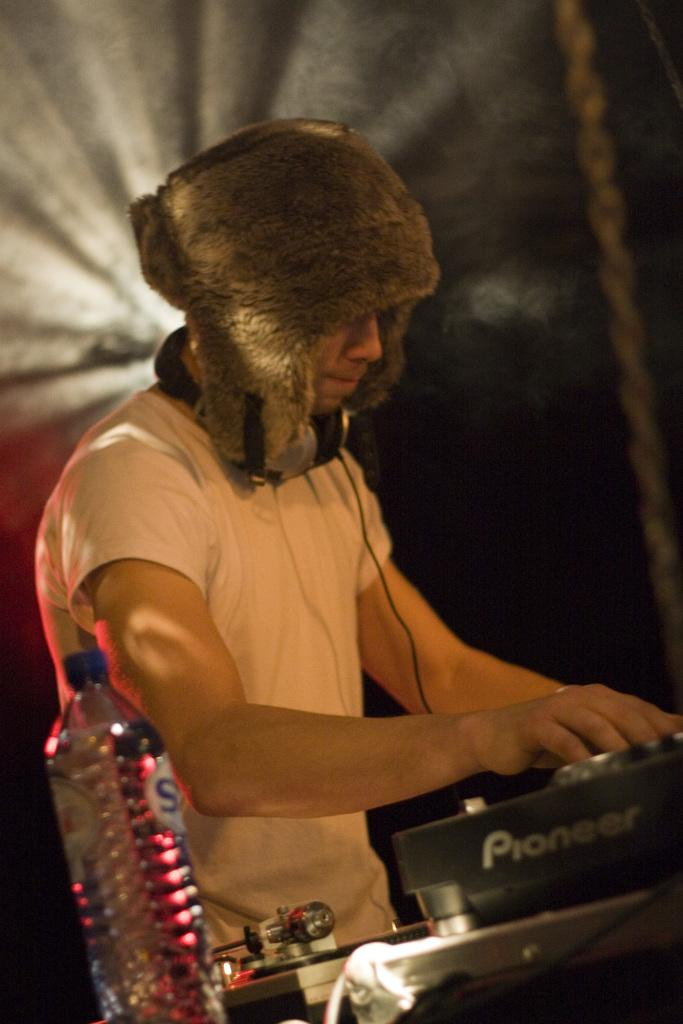What can be seen in the image? There is a person in the image. What is the person wearing on their head? The person is wearing a cap. What is the person holding around their neck? The person has a headset on their neck. What is in front of the person? There is a DJ controller in front of the person. What other object is visible in the image? There is a bottle in the image. What type of grain is being harvested by the cows in the image? There are no cows or grain present in the image; it features a person with a cap, headset, DJ controller, and a bottle. What invention is the person using to create new music in the image? The image does not show the person creating new music or using any specific invention; it only shows a DJ controller, which is a tool used by DJs to mix and manipulate audio. 